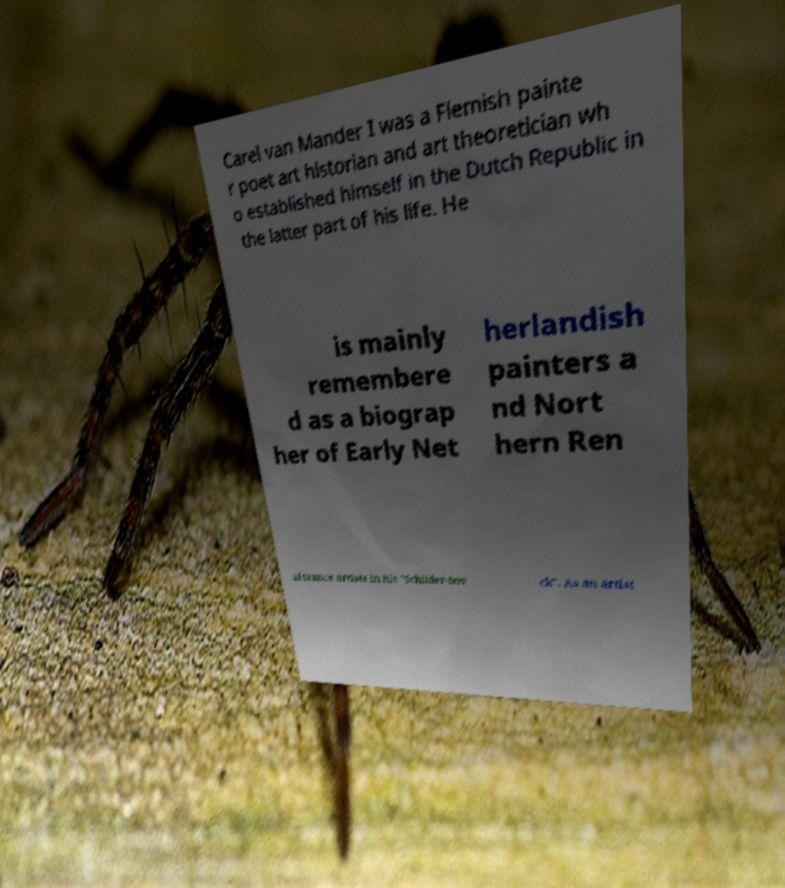Can you accurately transcribe the text from the provided image for me? Carel van Mander I was a Flemish painte r poet art historian and art theoretician wh o established himself in the Dutch Republic in the latter part of his life. He is mainly remembere d as a biograp her of Early Net herlandish painters a nd Nort hern Ren aissance artists in his "Schilder-boe ck". As an artist 